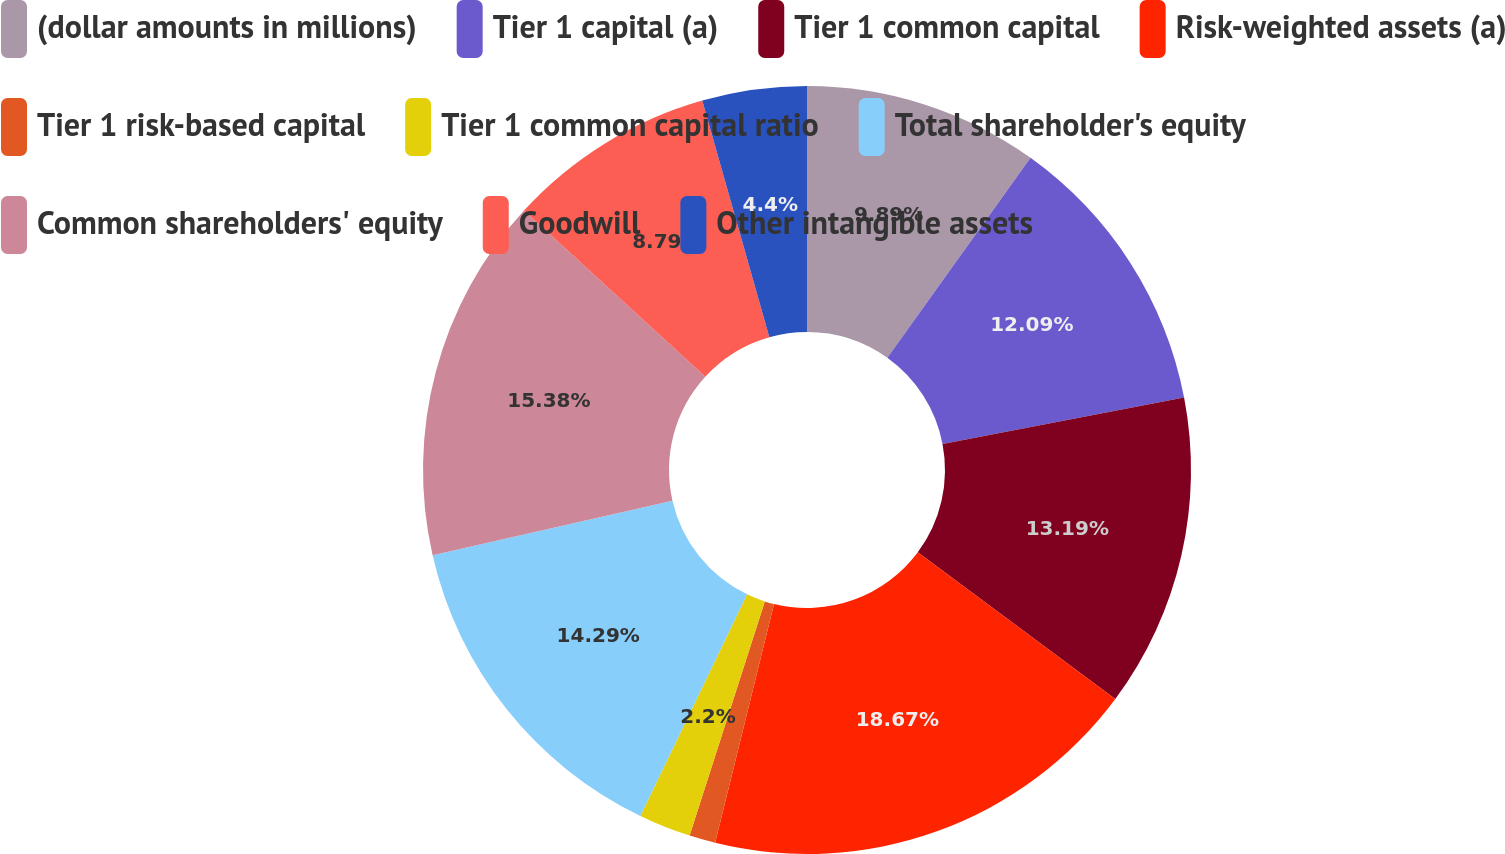<chart> <loc_0><loc_0><loc_500><loc_500><pie_chart><fcel>(dollar amounts in millions)<fcel>Tier 1 capital (a)<fcel>Tier 1 common capital<fcel>Risk-weighted assets (a)<fcel>Tier 1 risk-based capital<fcel>Tier 1 common capital ratio<fcel>Total shareholder's equity<fcel>Common shareholders' equity<fcel>Goodwill<fcel>Other intangible assets<nl><fcel>9.89%<fcel>12.09%<fcel>13.19%<fcel>18.68%<fcel>1.1%<fcel>2.2%<fcel>14.29%<fcel>15.38%<fcel>8.79%<fcel>4.4%<nl></chart> 